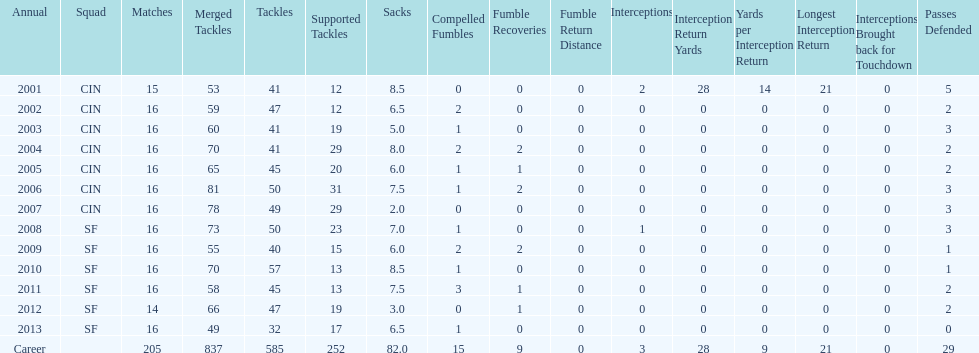What was the number of combined tackles in 2010? 70. 